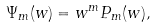<formula> <loc_0><loc_0><loc_500><loc_500>\Psi _ { m } ( w ) = w ^ { m } P _ { m } ( w ) ,</formula> 